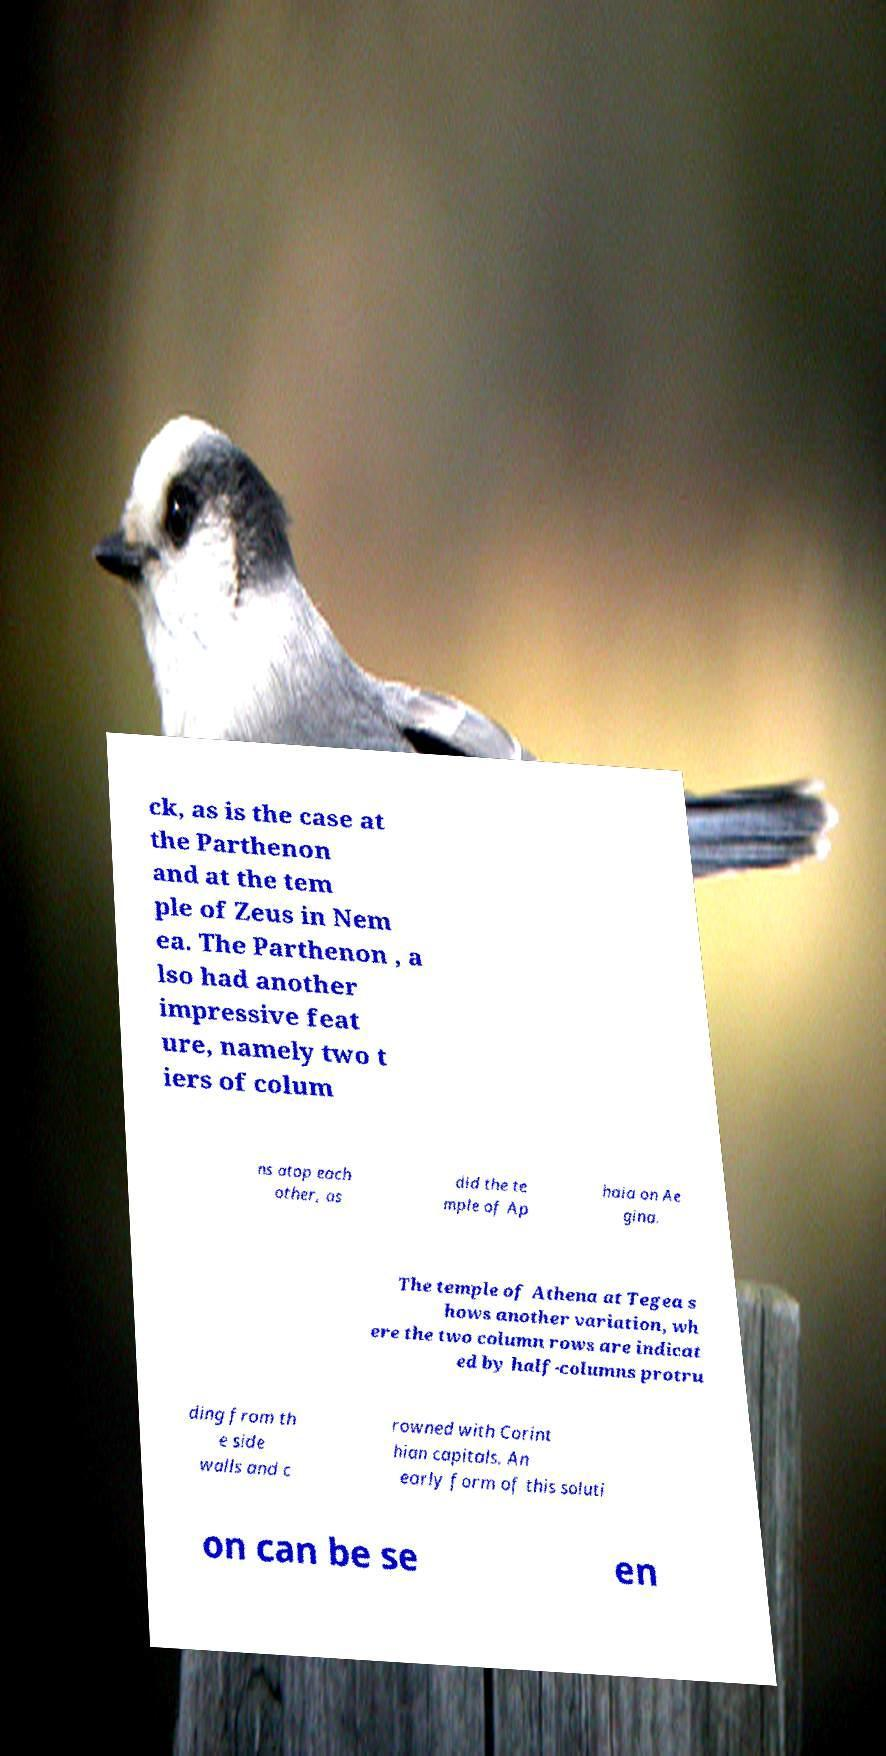Please identify and transcribe the text found in this image. ck, as is the case at the Parthenon and at the tem ple of Zeus in Nem ea. The Parthenon , a lso had another impressive feat ure, namely two t iers of colum ns atop each other, as did the te mple of Ap haia on Ae gina. The temple of Athena at Tegea s hows another variation, wh ere the two column rows are indicat ed by half-columns protru ding from th e side walls and c rowned with Corint hian capitals. An early form of this soluti on can be se en 